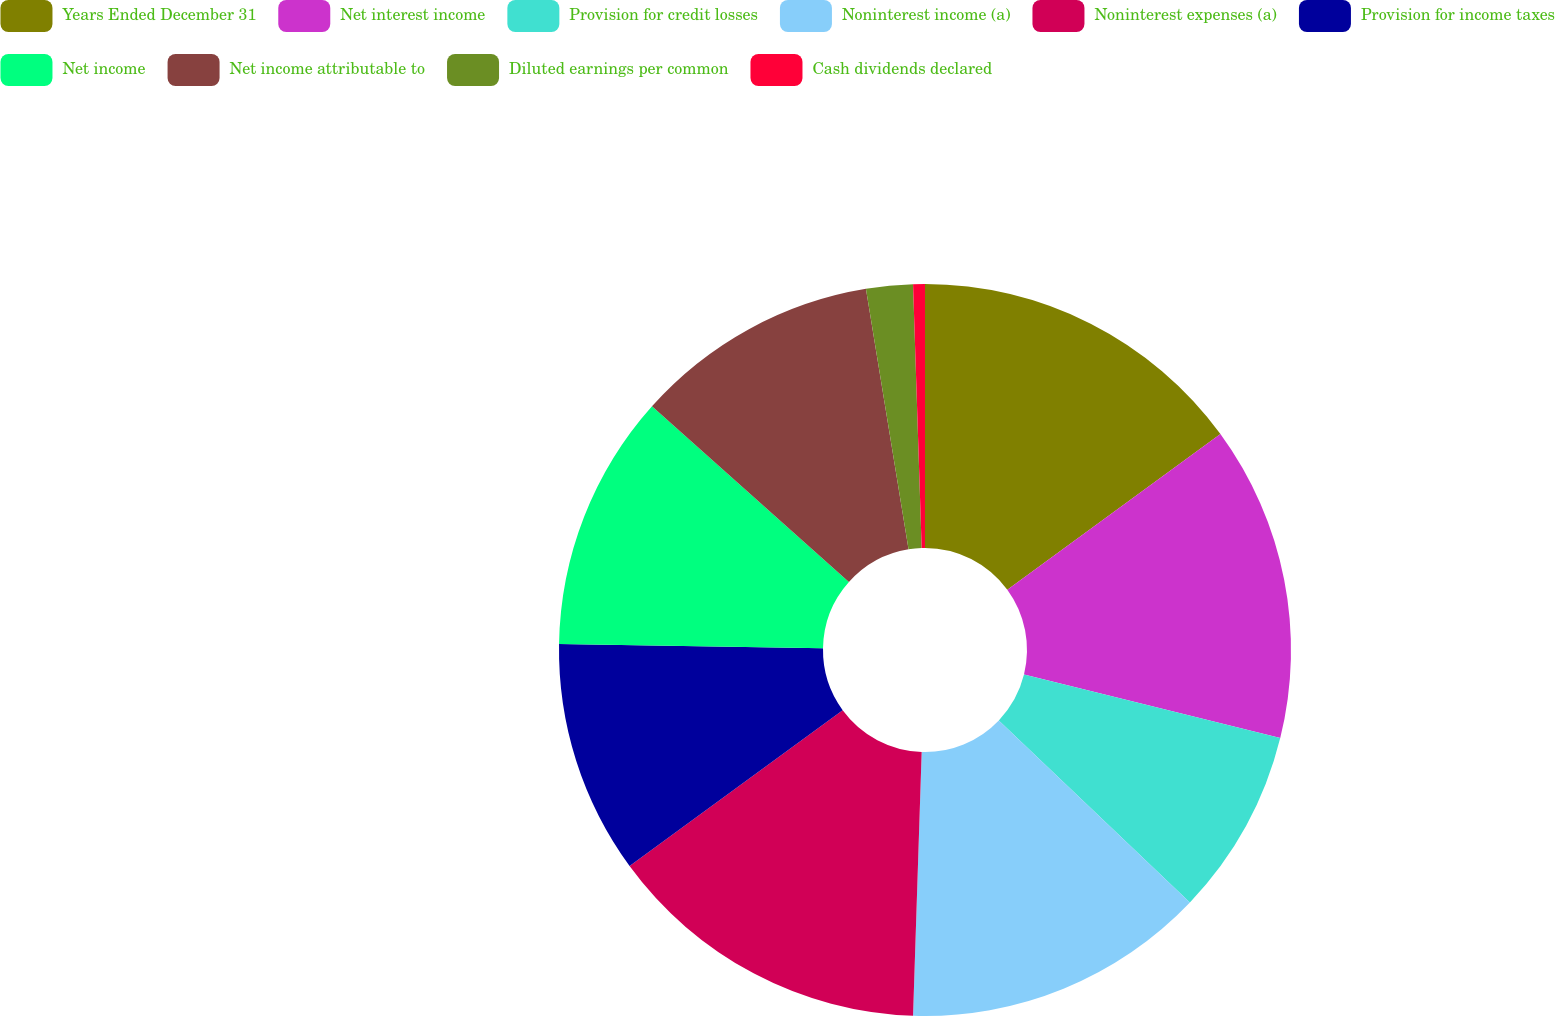Convert chart. <chart><loc_0><loc_0><loc_500><loc_500><pie_chart><fcel>Years Ended December 31<fcel>Net interest income<fcel>Provision for credit losses<fcel>Noninterest income (a)<fcel>Noninterest expenses (a)<fcel>Provision for income taxes<fcel>Net income<fcel>Net income attributable to<fcel>Diluted earnings per common<fcel>Cash dividends declared<nl><fcel>14.95%<fcel>13.92%<fcel>8.25%<fcel>13.4%<fcel>14.43%<fcel>10.31%<fcel>11.34%<fcel>10.82%<fcel>2.06%<fcel>0.52%<nl></chart> 